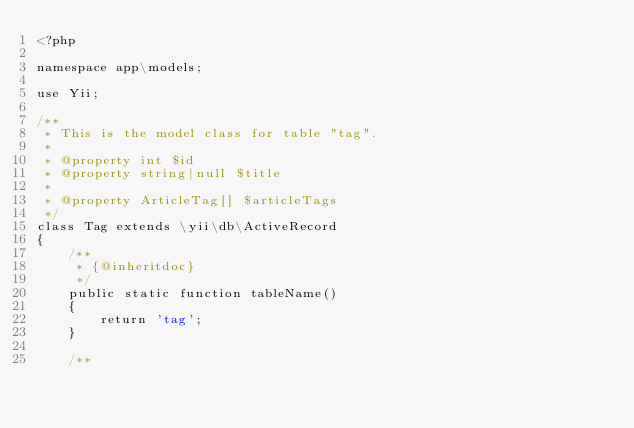<code> <loc_0><loc_0><loc_500><loc_500><_PHP_><?php

namespace app\models;

use Yii;

/**
 * This is the model class for table "tag".
 *
 * @property int $id
 * @property string|null $title
 *
 * @property ArticleTag[] $articleTags
 */
class Tag extends \yii\db\ActiveRecord
{
    /**
     * {@inheritdoc}
     */
    public static function tableName()
    {
        return 'tag';
    }

    /**</code> 